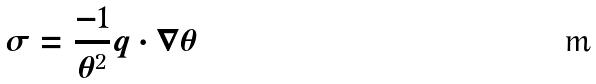<formula> <loc_0><loc_0><loc_500><loc_500>\sigma = \frac { - 1 } { \theta ^ { 2 } } q \cdot \nabla \theta</formula> 